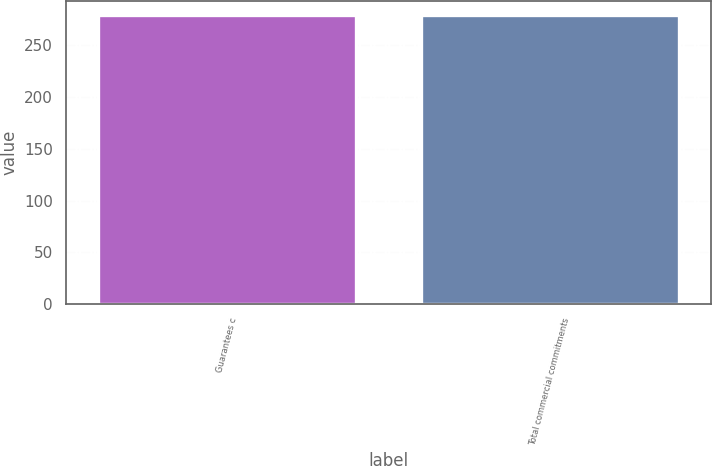Convert chart. <chart><loc_0><loc_0><loc_500><loc_500><bar_chart><fcel>Guarantees c<fcel>Total commercial commitments<nl><fcel>279<fcel>279.1<nl></chart> 